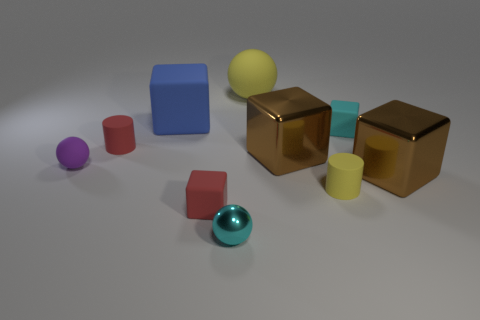Are there more yellow metallic blocks than tiny cyan matte blocks?
Your answer should be very brief. No. There is a small red thing on the left side of the large blue block; is its shape the same as the purple matte thing?
Provide a succinct answer. No. How many rubber things are small purple balls or small red blocks?
Your response must be concise. 2. Is there a big blue thing made of the same material as the small cyan cube?
Give a very brief answer. Yes. What is the material of the blue cube?
Provide a short and direct response. Rubber. There is a yellow matte thing that is behind the small cylinder behind the rubber cylinder that is on the right side of the big yellow sphere; what shape is it?
Your answer should be very brief. Sphere. Are there more tiny cyan metallic spheres to the right of the small cyan sphere than small cyan things?
Provide a succinct answer. No. There is a big blue rubber object; is its shape the same as the yellow rubber object in front of the red cylinder?
Offer a terse response. No. The tiny matte thing that is the same color as the big sphere is what shape?
Ensure brevity in your answer.  Cylinder. There is a tiny cyan thing in front of the rubber cylinder behind the yellow cylinder; what number of cylinders are to the right of it?
Offer a terse response. 1. 